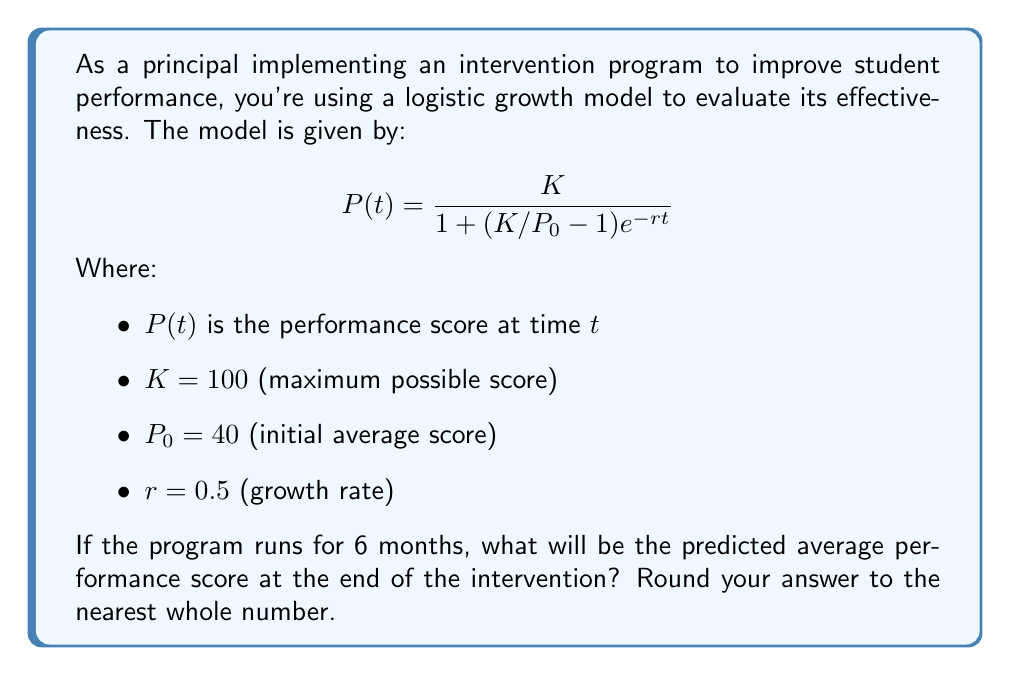Can you answer this question? To solve this problem, we'll follow these steps:

1) We have the logistic growth model:
   $$P(t) = \frac{K}{1 + (K/P_0 - 1)e^{-rt}}$$

2) We're given:
   $K = 100$
   $P_0 = 40$
   $r = 0.5$
   $t = 6$ (6 months)

3) Let's substitute these values into the equation:
   $$P(6) = \frac{100}{1 + (100/40 - 1)e^{-0.5(6)}}$$

4) Simplify inside the parentheses:
   $$P(6) = \frac{100}{1 + (2.5 - 1)e^{-3}}$$
   $$P(6) = \frac{100}{1 + 1.5e^{-3}}$$

5) Calculate $e^{-3}$:
   $e^{-3} \approx 0.0498$

6) Substitute this back:
   $$P(6) = \frac{100}{1 + 1.5(0.0498)}$$
   $$P(6) = \frac{100}{1 + 0.0747}$$
   $$P(6) = \frac{100}{1.0747}$$

7) Divide:
   $$P(6) \approx 93.05$$

8) Rounding to the nearest whole number:
   $$P(6) \approx 93$$

Therefore, the predicted average performance score after 6 months of intervention is 93.
Answer: 93 